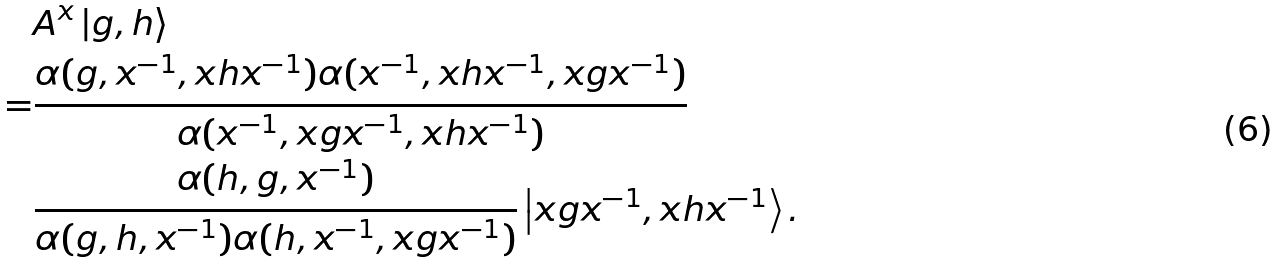<formula> <loc_0><loc_0><loc_500><loc_500>& A ^ { x } \left | g , h \right \rangle \\ = & \frac { \alpha ( g , x ^ { - 1 } , x h x ^ { - 1 } ) \alpha ( x ^ { - 1 } , x h x ^ { - 1 } , x g x ^ { - 1 } ) } { \alpha ( x ^ { - 1 } , x g x ^ { - 1 } , x h x ^ { - 1 } ) } \\ & \frac { \alpha ( h , g , x ^ { - 1 } ) } { \alpha ( g , h , x ^ { - 1 } ) \alpha ( h , x ^ { - 1 } , x g x ^ { - 1 } ) } \left | x g x ^ { - 1 } , x h x ^ { - 1 } \right \rangle .</formula> 